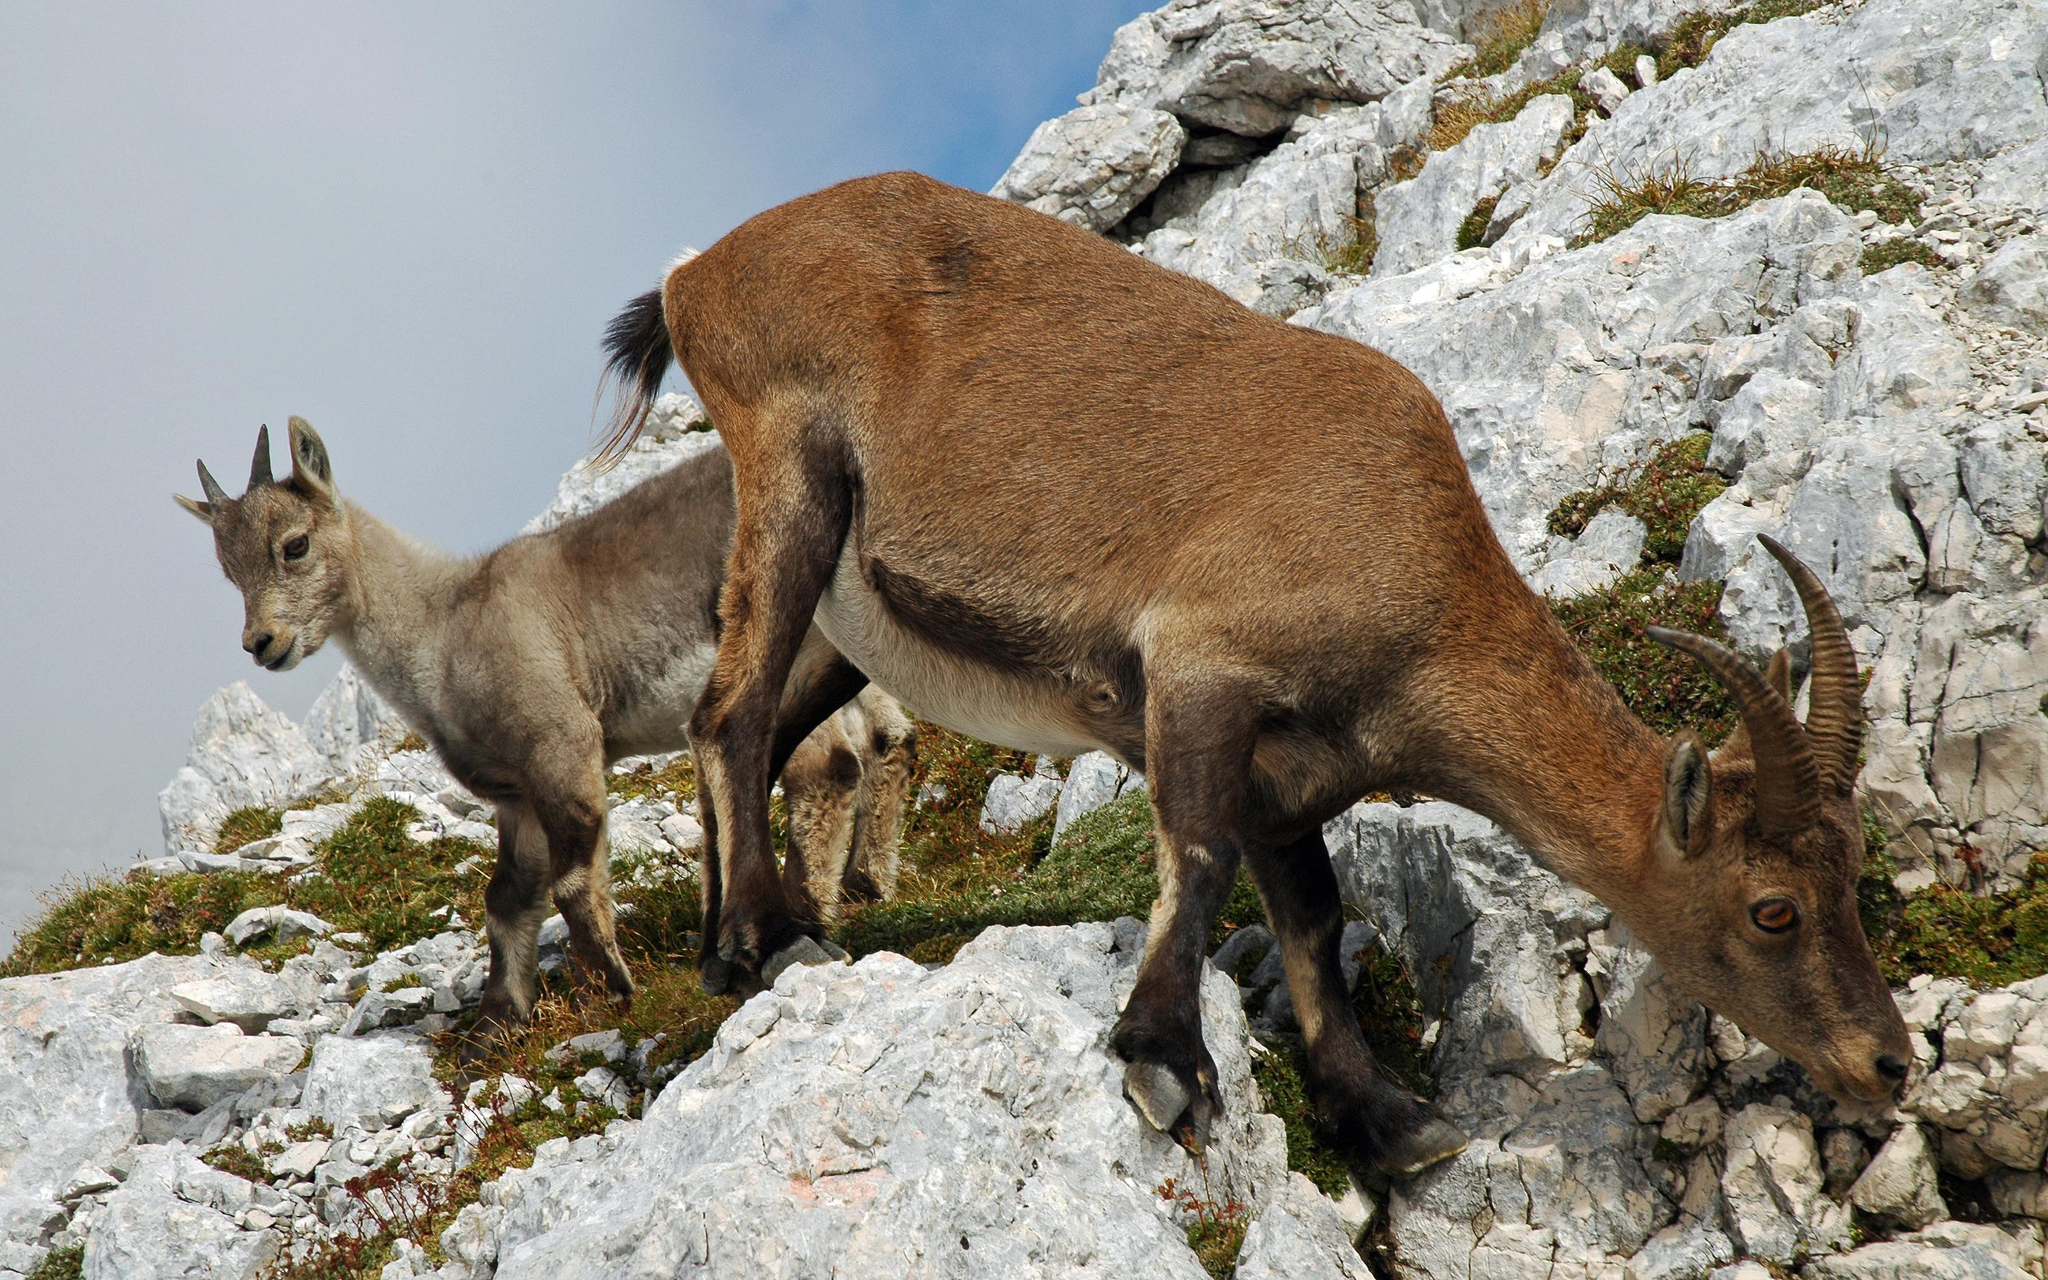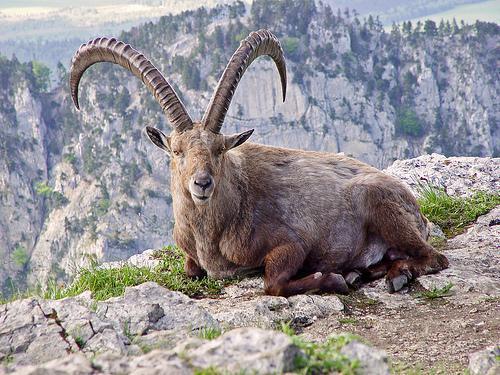The first image is the image on the left, the second image is the image on the right. For the images displayed, is the sentence "An image shows a younger goat standing near an adult goat." factually correct? Answer yes or no. Yes. 